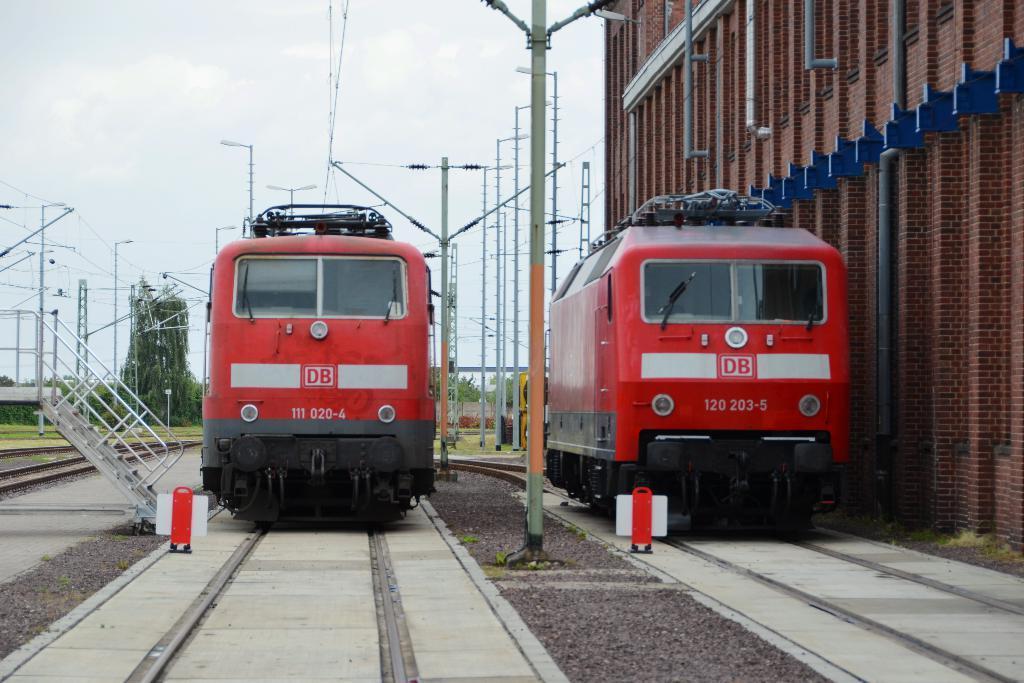Can you describe this image briefly? In this image I can see red color trains on railway tracks. In the background I can see pole lights, wires, trees and the sky. Here I can see a building and other objects on the ground. 